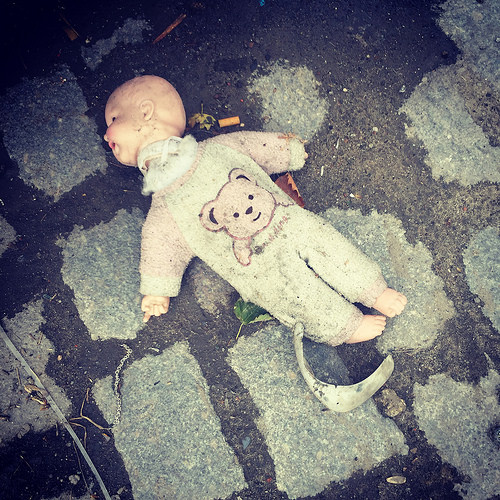<image>
Can you confirm if the chain is in front of the cigarette butt? No. The chain is not in front of the cigarette butt. The spatial positioning shows a different relationship between these objects. 